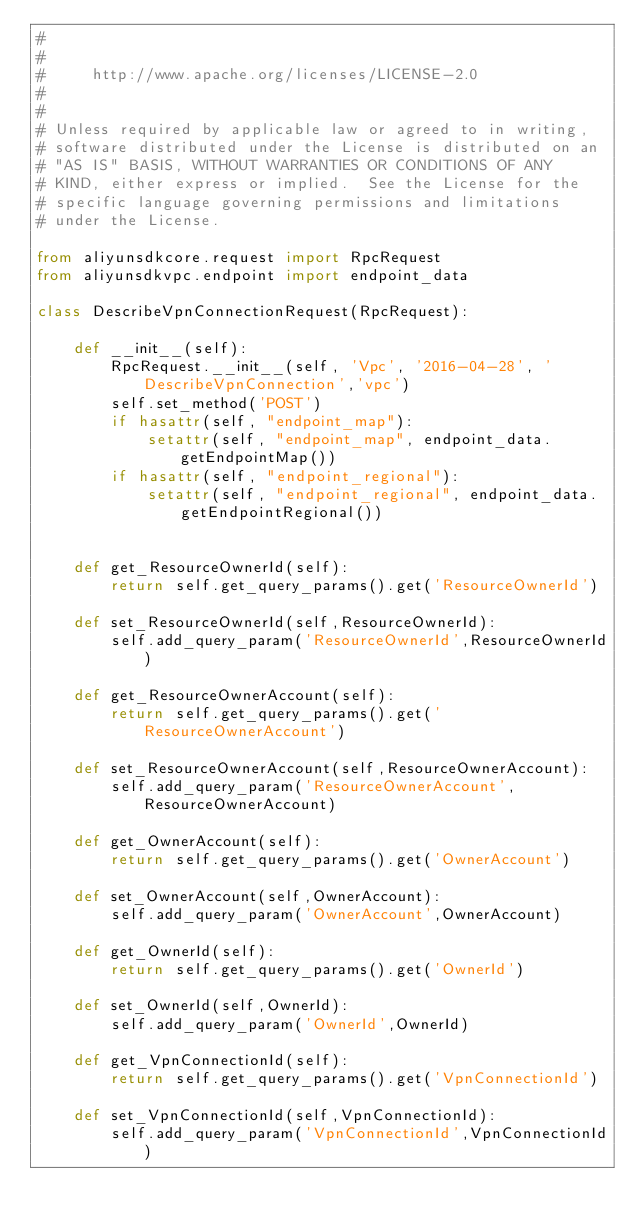Convert code to text. <code><loc_0><loc_0><loc_500><loc_500><_Python_>#
#
#     http://www.apache.org/licenses/LICENSE-2.0
#
#
# Unless required by applicable law or agreed to in writing,
# software distributed under the License is distributed on an
# "AS IS" BASIS, WITHOUT WARRANTIES OR CONDITIONS OF ANY
# KIND, either express or implied.  See the License for the
# specific language governing permissions and limitations
# under the License.

from aliyunsdkcore.request import RpcRequest
from aliyunsdkvpc.endpoint import endpoint_data

class DescribeVpnConnectionRequest(RpcRequest):

	def __init__(self):
		RpcRequest.__init__(self, 'Vpc', '2016-04-28', 'DescribeVpnConnection','vpc')
		self.set_method('POST')
		if hasattr(self, "endpoint_map"):
			setattr(self, "endpoint_map", endpoint_data.getEndpointMap())
		if hasattr(self, "endpoint_regional"):
			setattr(self, "endpoint_regional", endpoint_data.getEndpointRegional())


	def get_ResourceOwnerId(self):
		return self.get_query_params().get('ResourceOwnerId')

	def set_ResourceOwnerId(self,ResourceOwnerId):
		self.add_query_param('ResourceOwnerId',ResourceOwnerId)

	def get_ResourceOwnerAccount(self):
		return self.get_query_params().get('ResourceOwnerAccount')

	def set_ResourceOwnerAccount(self,ResourceOwnerAccount):
		self.add_query_param('ResourceOwnerAccount',ResourceOwnerAccount)

	def get_OwnerAccount(self):
		return self.get_query_params().get('OwnerAccount')

	def set_OwnerAccount(self,OwnerAccount):
		self.add_query_param('OwnerAccount',OwnerAccount)

	def get_OwnerId(self):
		return self.get_query_params().get('OwnerId')

	def set_OwnerId(self,OwnerId):
		self.add_query_param('OwnerId',OwnerId)

	def get_VpnConnectionId(self):
		return self.get_query_params().get('VpnConnectionId')

	def set_VpnConnectionId(self,VpnConnectionId):
		self.add_query_param('VpnConnectionId',VpnConnectionId)</code> 